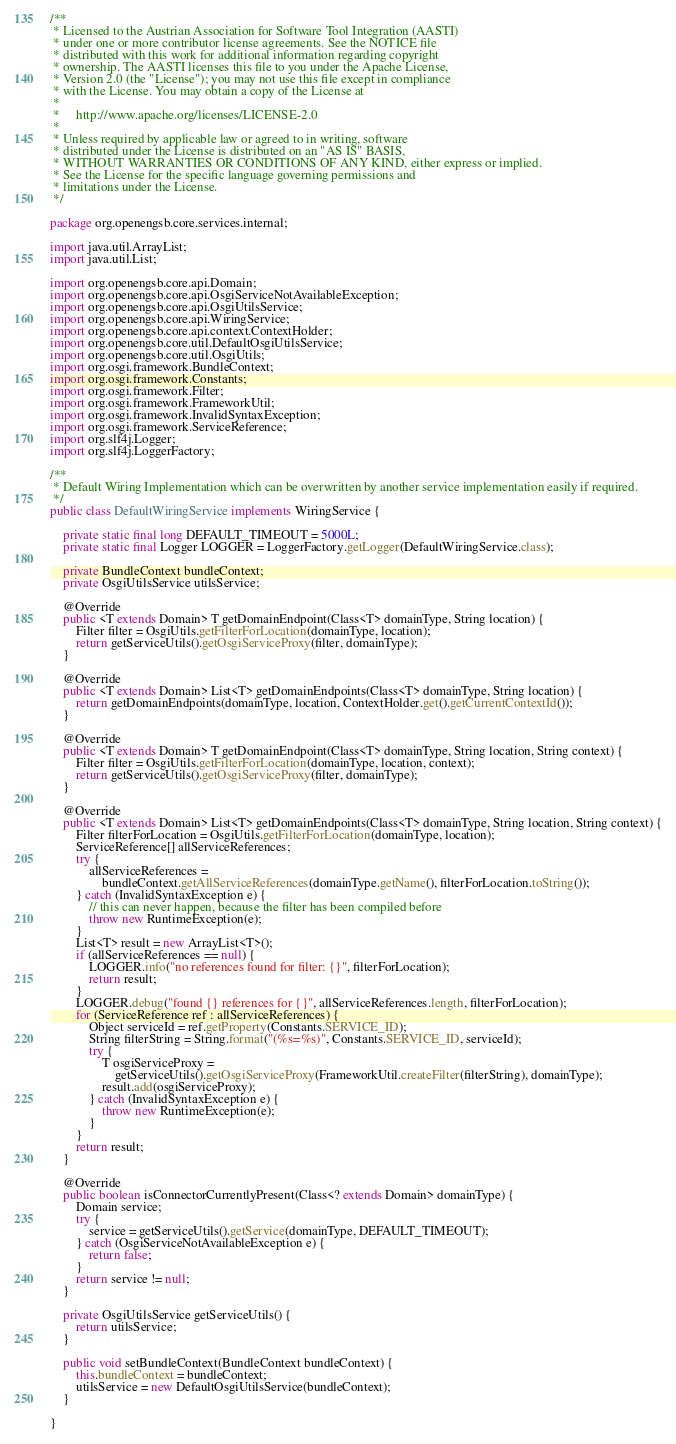<code> <loc_0><loc_0><loc_500><loc_500><_Java_>/**
 * Licensed to the Austrian Association for Software Tool Integration (AASTI)
 * under one or more contributor license agreements. See the NOTICE file
 * distributed with this work for additional information regarding copyright
 * ownership. The AASTI licenses this file to you under the Apache License,
 * Version 2.0 (the "License"); you may not use this file except in compliance
 * with the License. You may obtain a copy of the License at
 *
 *     http://www.apache.org/licenses/LICENSE-2.0
 *
 * Unless required by applicable law or agreed to in writing, software
 * distributed under the License is distributed on an "AS IS" BASIS,
 * WITHOUT WARRANTIES OR CONDITIONS OF ANY KIND, either express or implied.
 * See the License for the specific language governing permissions and
 * limitations under the License.
 */

package org.openengsb.core.services.internal;

import java.util.ArrayList;
import java.util.List;

import org.openengsb.core.api.Domain;
import org.openengsb.core.api.OsgiServiceNotAvailableException;
import org.openengsb.core.api.OsgiUtilsService;
import org.openengsb.core.api.WiringService;
import org.openengsb.core.api.context.ContextHolder;
import org.openengsb.core.util.DefaultOsgiUtilsService;
import org.openengsb.core.util.OsgiUtils;
import org.osgi.framework.BundleContext;
import org.osgi.framework.Constants;
import org.osgi.framework.Filter;
import org.osgi.framework.FrameworkUtil;
import org.osgi.framework.InvalidSyntaxException;
import org.osgi.framework.ServiceReference;
import org.slf4j.Logger;
import org.slf4j.LoggerFactory;

/**
 * Default Wiring Implementation which can be overwritten by another service implementation easily if required.
 */
public class DefaultWiringService implements WiringService {

    private static final long DEFAULT_TIMEOUT = 5000L;
    private static final Logger LOGGER = LoggerFactory.getLogger(DefaultWiringService.class);

    private BundleContext bundleContext;
    private OsgiUtilsService utilsService;

    @Override
    public <T extends Domain> T getDomainEndpoint(Class<T> domainType, String location) {
        Filter filter = OsgiUtils.getFilterForLocation(domainType, location);
        return getServiceUtils().getOsgiServiceProxy(filter, domainType);
    }

    @Override
    public <T extends Domain> List<T> getDomainEndpoints(Class<T> domainType, String location) {
        return getDomainEndpoints(domainType, location, ContextHolder.get().getCurrentContextId());
    }

    @Override
    public <T extends Domain> T getDomainEndpoint(Class<T> domainType, String location, String context) {
        Filter filter = OsgiUtils.getFilterForLocation(domainType, location, context);
        return getServiceUtils().getOsgiServiceProxy(filter, domainType);
    }

    @Override
    public <T extends Domain> List<T> getDomainEndpoints(Class<T> domainType, String location, String context) {
        Filter filterForLocation = OsgiUtils.getFilterForLocation(domainType, location);
        ServiceReference[] allServiceReferences;
        try {
            allServiceReferences =
                bundleContext.getAllServiceReferences(domainType.getName(), filterForLocation.toString());
        } catch (InvalidSyntaxException e) {
            // this can never happen, because the filter has been compiled before
            throw new RuntimeException(e);
        }
        List<T> result = new ArrayList<T>();
        if (allServiceReferences == null) {
            LOGGER.info("no references found for filter: {}", filterForLocation);
            return result;
        }
        LOGGER.debug("found {} references for {}", allServiceReferences.length, filterForLocation);
        for (ServiceReference ref : allServiceReferences) {
            Object serviceId = ref.getProperty(Constants.SERVICE_ID);
            String filterString = String.format("(%s=%s)", Constants.SERVICE_ID, serviceId);
            try {
                T osgiServiceProxy =
                    getServiceUtils().getOsgiServiceProxy(FrameworkUtil.createFilter(filterString), domainType);
                result.add(osgiServiceProxy);
            } catch (InvalidSyntaxException e) {
                throw new RuntimeException(e);
            }
        }
        return result;
    }

    @Override
    public boolean isConnectorCurrentlyPresent(Class<? extends Domain> domainType) {
        Domain service;
        try {
            service = getServiceUtils().getService(domainType, DEFAULT_TIMEOUT);
        } catch (OsgiServiceNotAvailableException e) {
            return false;
        }
        return service != null;
    }

    private OsgiUtilsService getServiceUtils() {
        return utilsService;
    }

    public void setBundleContext(BundleContext bundleContext) {
        this.bundleContext = bundleContext;
        utilsService = new DefaultOsgiUtilsService(bundleContext);
    }

}
</code> 